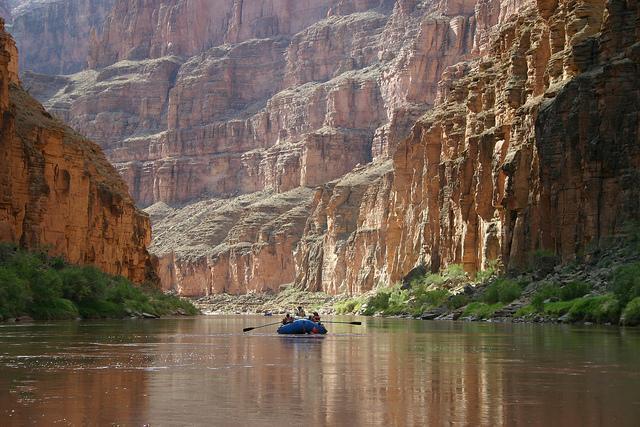How many colorful umbrellas are there?
Give a very brief answer. 0. 